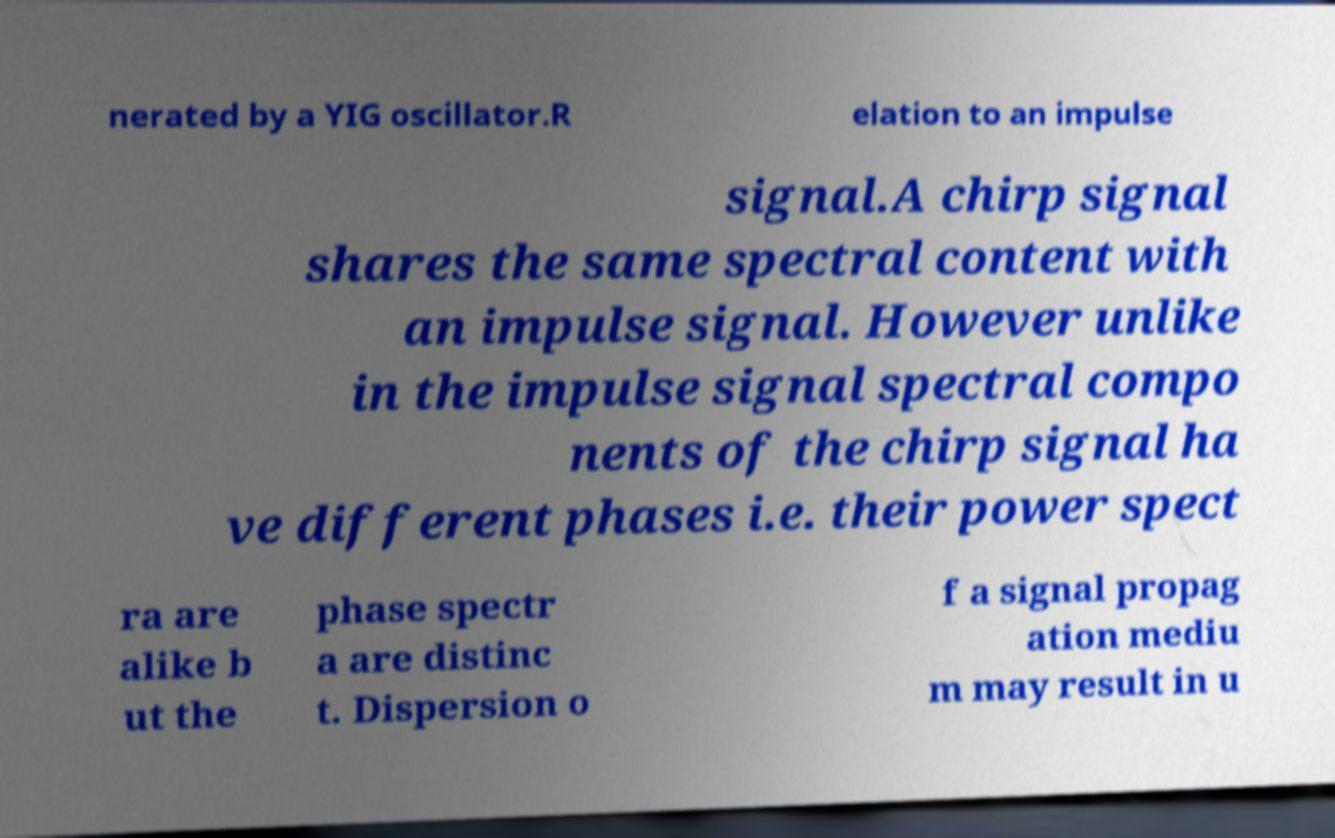For documentation purposes, I need the text within this image transcribed. Could you provide that? nerated by a YIG oscillator.R elation to an impulse signal.A chirp signal shares the same spectral content with an impulse signal. However unlike in the impulse signal spectral compo nents of the chirp signal ha ve different phases i.e. their power spect ra are alike b ut the phase spectr a are distinc t. Dispersion o f a signal propag ation mediu m may result in u 